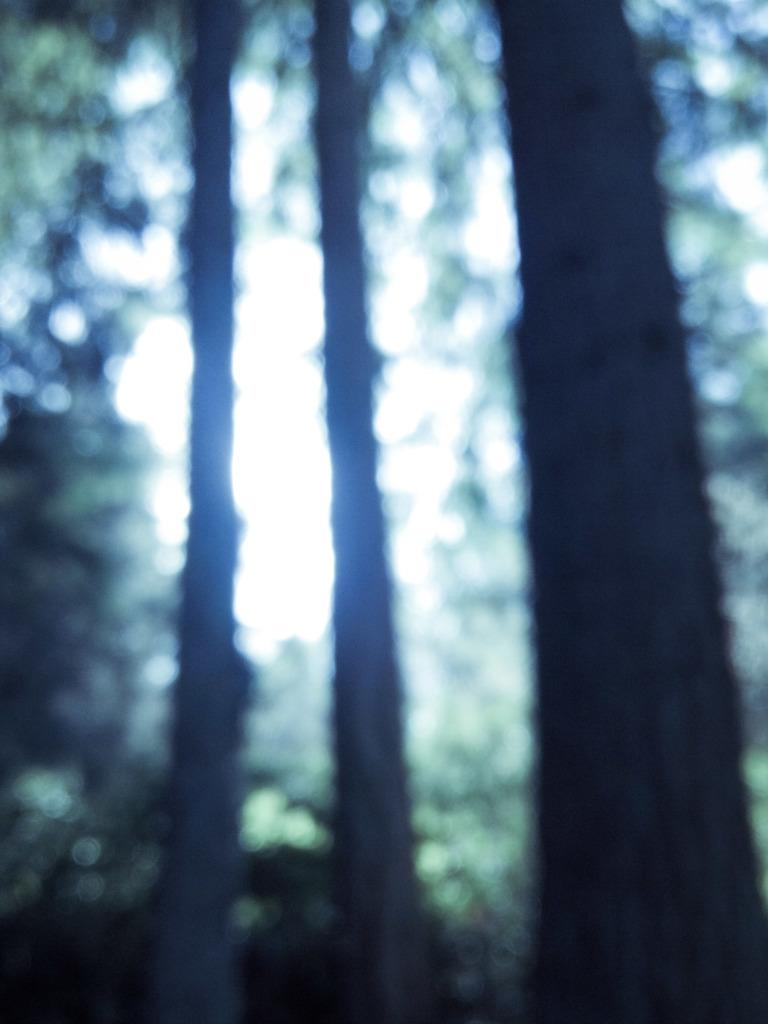What is the overall quality of the image? The image is blurry. What type of natural environment can be seen in the image? There are trees visible in the image. What part of the natural environment is also visible in the image? The sky is visible in the image. What type of cloud can be seen around the neck of the person in the image? There is no person present in the image, and therefore no neck or cloud can be observed. 